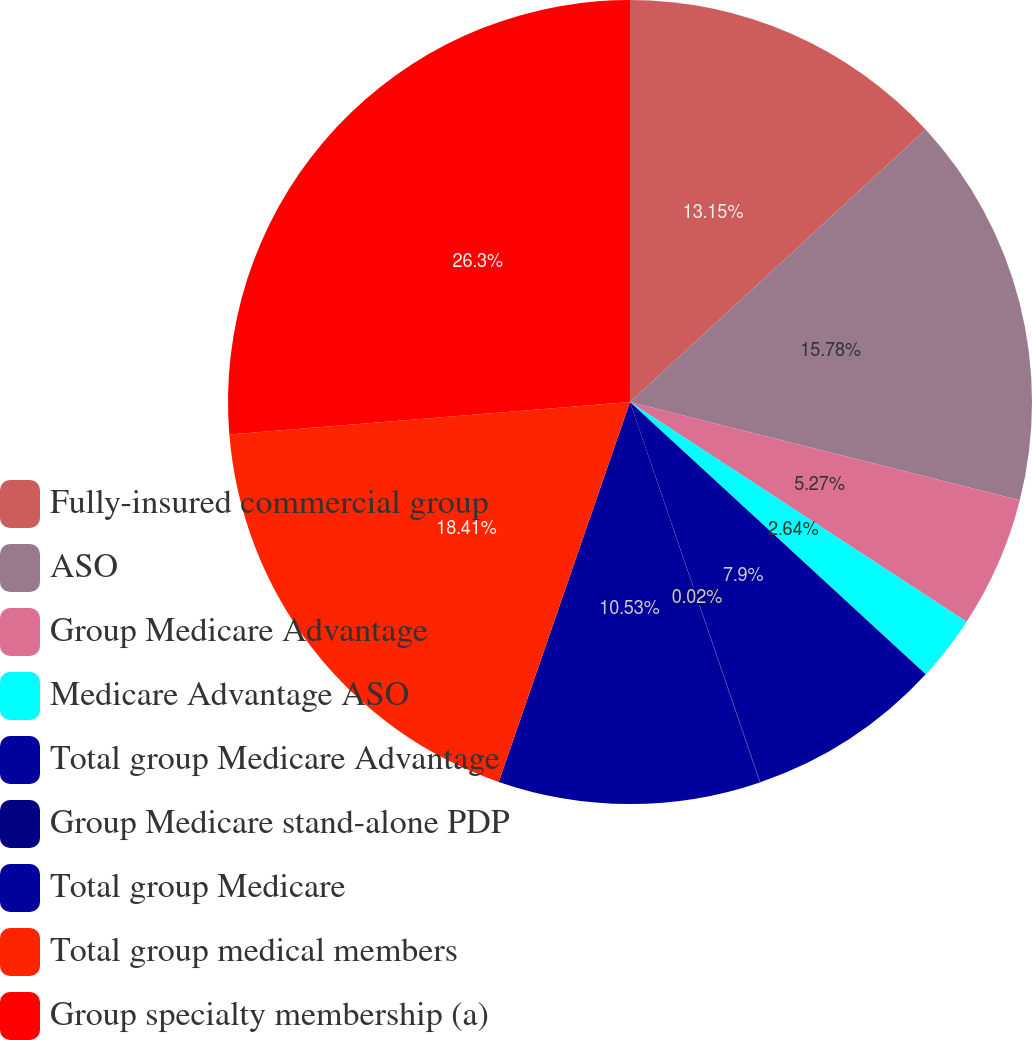Convert chart to OTSL. <chart><loc_0><loc_0><loc_500><loc_500><pie_chart><fcel>Fully-insured commercial group<fcel>ASO<fcel>Group Medicare Advantage<fcel>Medicare Advantage ASO<fcel>Total group Medicare Advantage<fcel>Group Medicare stand-alone PDP<fcel>Total group Medicare<fcel>Total group medical members<fcel>Group specialty membership (a)<nl><fcel>13.15%<fcel>15.78%<fcel>5.27%<fcel>2.64%<fcel>7.9%<fcel>0.02%<fcel>10.53%<fcel>18.41%<fcel>26.29%<nl></chart> 